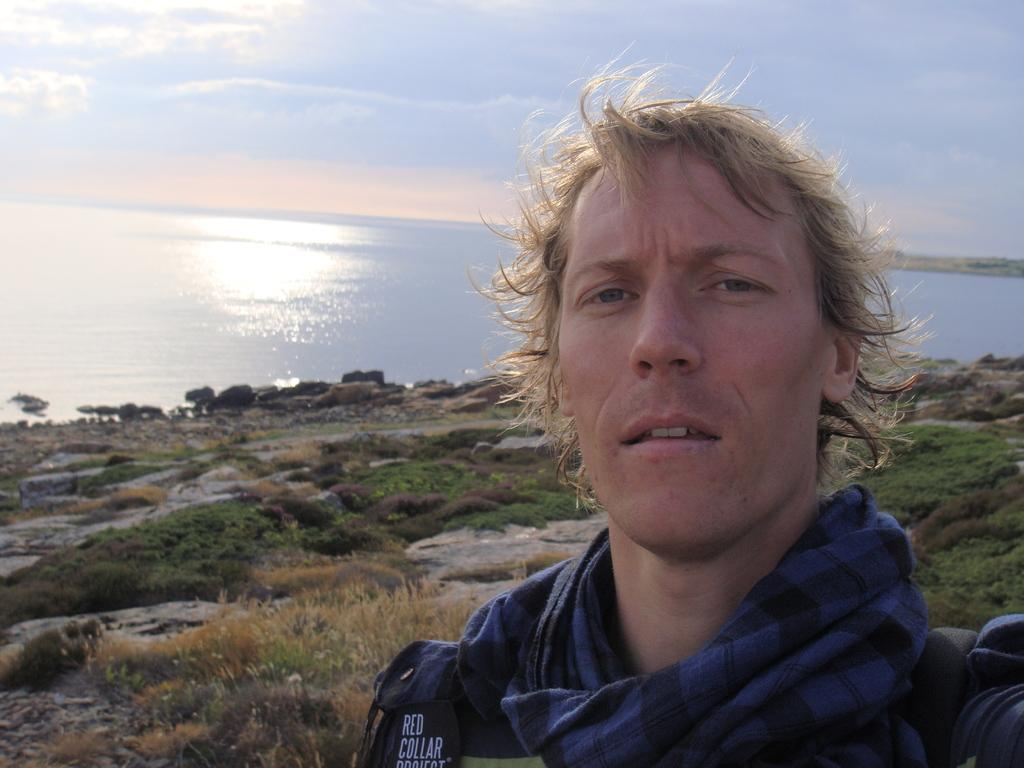Who is present in the image? There is a man in the image. What type of terrain is visible in the image? There is grass and stones visible in the image. What natural element can be seen in the image? There is water visible in the image. What is visible in the background of the image? The sky is visible in the image. How many rabbits are hopping on the rail in the image? There are no rabbits or rails present in the image. What type of insect can be seen flying near the water in the image? There is no insect visible in the image. 